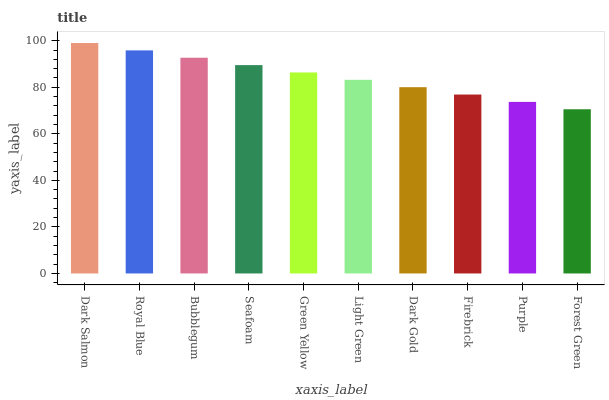Is Royal Blue the minimum?
Answer yes or no. No. Is Royal Blue the maximum?
Answer yes or no. No. Is Dark Salmon greater than Royal Blue?
Answer yes or no. Yes. Is Royal Blue less than Dark Salmon?
Answer yes or no. Yes. Is Royal Blue greater than Dark Salmon?
Answer yes or no. No. Is Dark Salmon less than Royal Blue?
Answer yes or no. No. Is Green Yellow the high median?
Answer yes or no. Yes. Is Light Green the low median?
Answer yes or no. Yes. Is Dark Gold the high median?
Answer yes or no. No. Is Firebrick the low median?
Answer yes or no. No. 